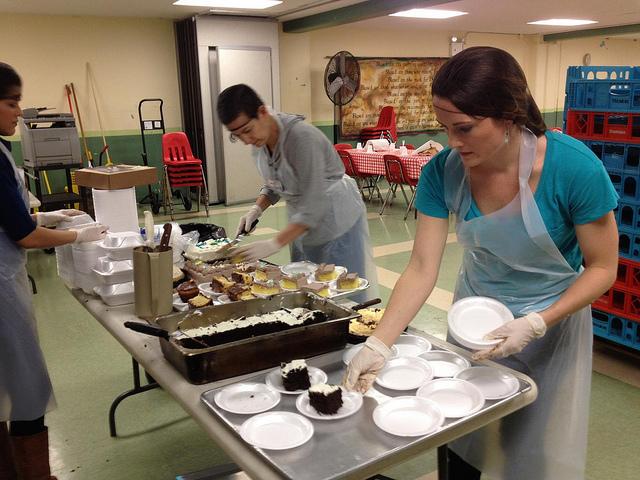What are they wearing on their heads?
Give a very brief answer. Hair nets. How many people are here?
Keep it brief. 3. Who are they serving?
Short answer required. Homeless. Where is the tall fan?
Be succinct. Corner. 